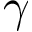Convert formula to latex. <formula><loc_0><loc_0><loc_500><loc_500>\gamma</formula> 